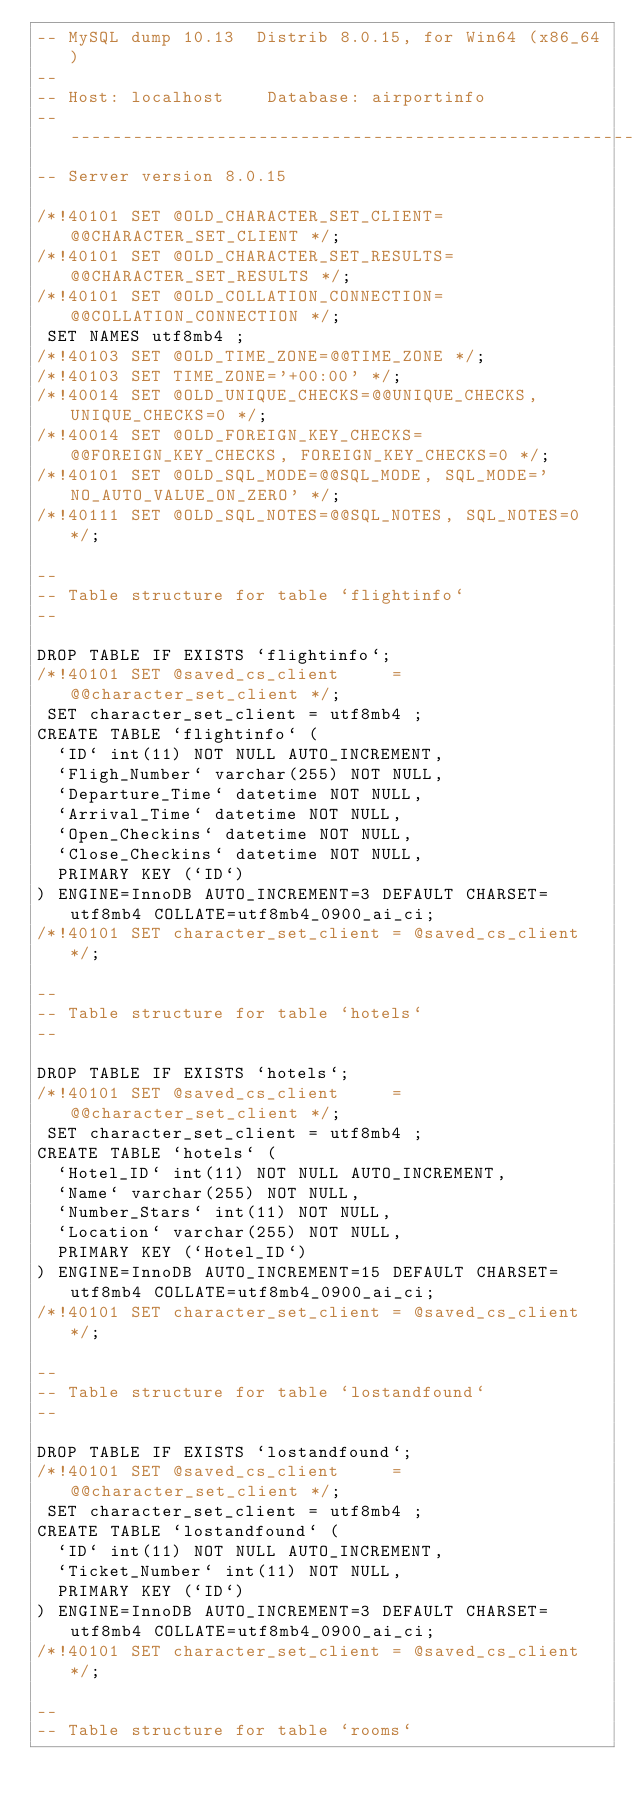Convert code to text. <code><loc_0><loc_0><loc_500><loc_500><_SQL_>-- MySQL dump 10.13  Distrib 8.0.15, for Win64 (x86_64)
--
-- Host: localhost    Database: airportinfo
-- ------------------------------------------------------
-- Server version	8.0.15

/*!40101 SET @OLD_CHARACTER_SET_CLIENT=@@CHARACTER_SET_CLIENT */;
/*!40101 SET @OLD_CHARACTER_SET_RESULTS=@@CHARACTER_SET_RESULTS */;
/*!40101 SET @OLD_COLLATION_CONNECTION=@@COLLATION_CONNECTION */;
 SET NAMES utf8mb4 ;
/*!40103 SET @OLD_TIME_ZONE=@@TIME_ZONE */;
/*!40103 SET TIME_ZONE='+00:00' */;
/*!40014 SET @OLD_UNIQUE_CHECKS=@@UNIQUE_CHECKS, UNIQUE_CHECKS=0 */;
/*!40014 SET @OLD_FOREIGN_KEY_CHECKS=@@FOREIGN_KEY_CHECKS, FOREIGN_KEY_CHECKS=0 */;
/*!40101 SET @OLD_SQL_MODE=@@SQL_MODE, SQL_MODE='NO_AUTO_VALUE_ON_ZERO' */;
/*!40111 SET @OLD_SQL_NOTES=@@SQL_NOTES, SQL_NOTES=0 */;

--
-- Table structure for table `flightinfo`
--

DROP TABLE IF EXISTS `flightinfo`;
/*!40101 SET @saved_cs_client     = @@character_set_client */;
 SET character_set_client = utf8mb4 ;
CREATE TABLE `flightinfo` (
  `ID` int(11) NOT NULL AUTO_INCREMENT,
  `Fligh_Number` varchar(255) NOT NULL,
  `Departure_Time` datetime NOT NULL,
  `Arrival_Time` datetime NOT NULL,
  `Open_Checkins` datetime NOT NULL,
  `Close_Checkins` datetime NOT NULL,
  PRIMARY KEY (`ID`)
) ENGINE=InnoDB AUTO_INCREMENT=3 DEFAULT CHARSET=utf8mb4 COLLATE=utf8mb4_0900_ai_ci;
/*!40101 SET character_set_client = @saved_cs_client */;

--
-- Table structure for table `hotels`
--

DROP TABLE IF EXISTS `hotels`;
/*!40101 SET @saved_cs_client     = @@character_set_client */;
 SET character_set_client = utf8mb4 ;
CREATE TABLE `hotels` (
  `Hotel_ID` int(11) NOT NULL AUTO_INCREMENT,
  `Name` varchar(255) NOT NULL,
  `Number_Stars` int(11) NOT NULL,
  `Location` varchar(255) NOT NULL,
  PRIMARY KEY (`Hotel_ID`)
) ENGINE=InnoDB AUTO_INCREMENT=15 DEFAULT CHARSET=utf8mb4 COLLATE=utf8mb4_0900_ai_ci;
/*!40101 SET character_set_client = @saved_cs_client */;

--
-- Table structure for table `lostandfound`
--

DROP TABLE IF EXISTS `lostandfound`;
/*!40101 SET @saved_cs_client     = @@character_set_client */;
 SET character_set_client = utf8mb4 ;
CREATE TABLE `lostandfound` (
  `ID` int(11) NOT NULL AUTO_INCREMENT,
  `Ticket_Number` int(11) NOT NULL,
  PRIMARY KEY (`ID`)
) ENGINE=InnoDB AUTO_INCREMENT=3 DEFAULT CHARSET=utf8mb4 COLLATE=utf8mb4_0900_ai_ci;
/*!40101 SET character_set_client = @saved_cs_client */;

--
-- Table structure for table `rooms`</code> 